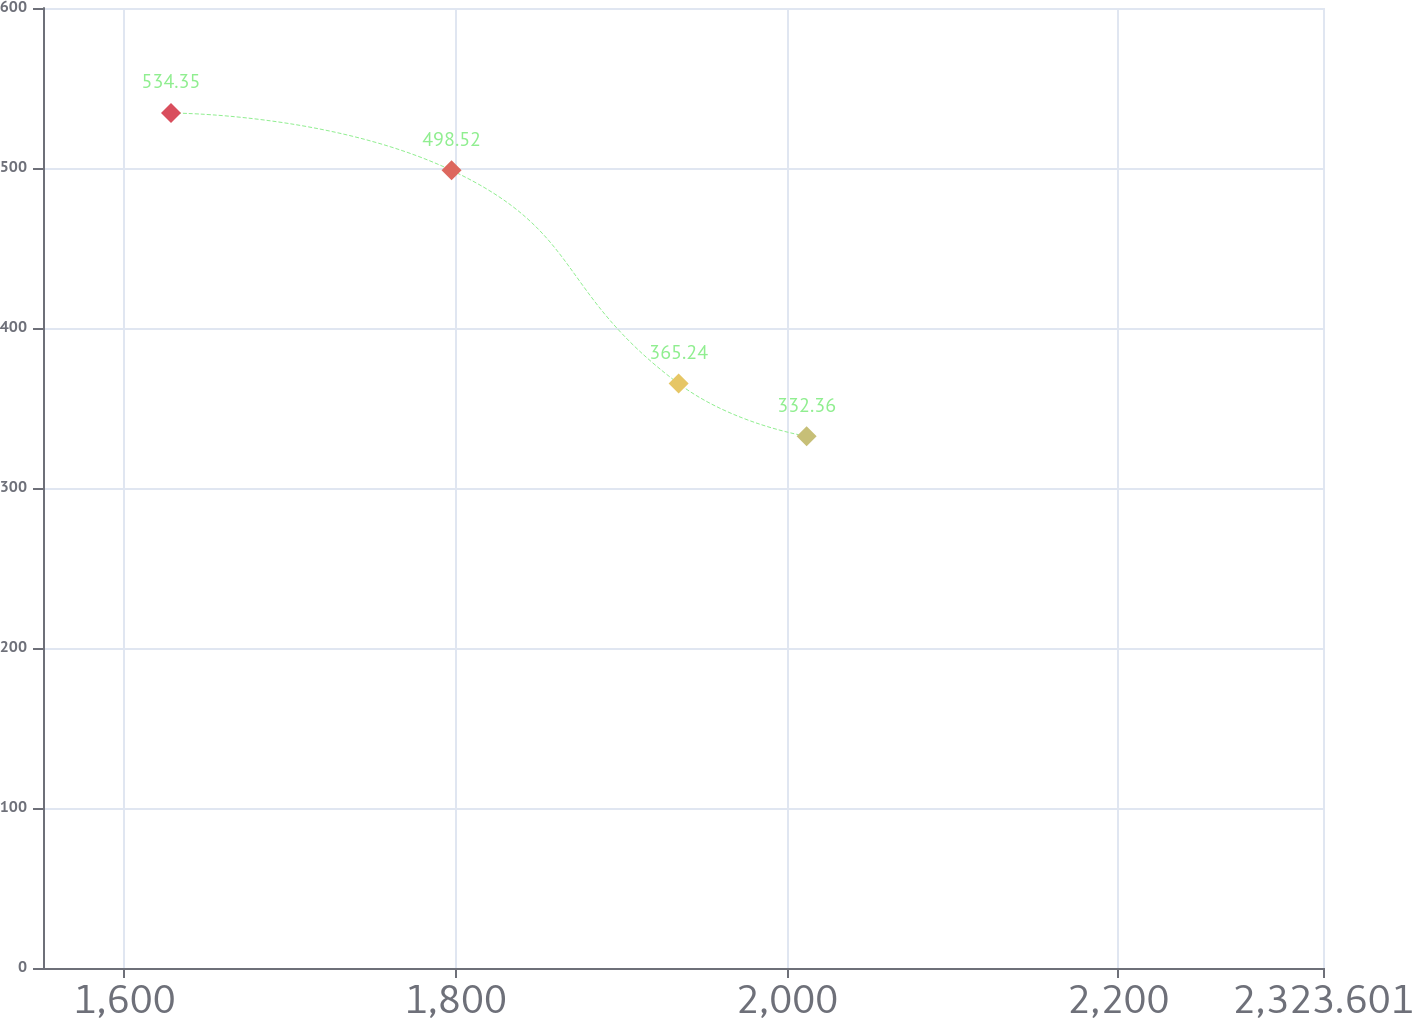<chart> <loc_0><loc_0><loc_500><loc_500><line_chart><ecel><fcel>Unnamed: 1<nl><fcel>1628.09<fcel>534.35<nl><fcel>1797.49<fcel>498.52<nl><fcel>1934.58<fcel>365.24<nl><fcel>2011.86<fcel>332.36<nl><fcel>2400.88<fcel>205.51<nl></chart> 